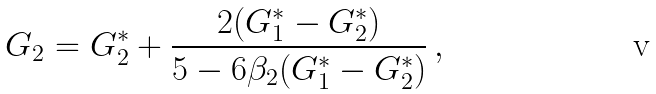<formula> <loc_0><loc_0><loc_500><loc_500>G _ { 2 } = G _ { 2 } ^ { * } + \frac { 2 ( G _ { 1 } ^ { * } - G _ { 2 } ^ { * } ) } { 5 - 6 \beta _ { 2 } ( G _ { 1 } ^ { * } - G _ { 2 } ^ { * } ) } \, ,</formula> 